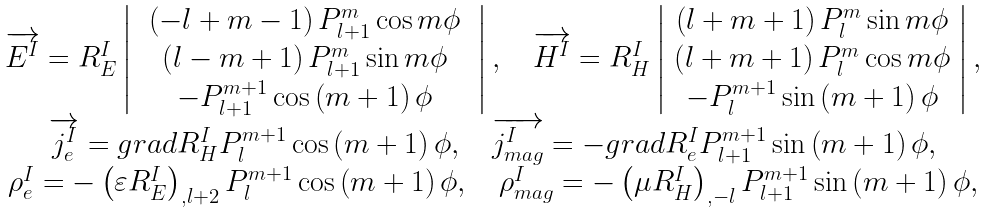Convert formula to latex. <formula><loc_0><loc_0><loc_500><loc_500>\begin{array} { c } \overrightarrow { E ^ { I } } = R _ { E } ^ { I } \left | \begin{array} { c } \begin{array} { c } \left ( - l + m - 1 \right ) P _ { l + 1 } ^ { m } \cos m \phi \\ \left ( l - m + 1 \right ) P _ { l + 1 } ^ { m } \sin m \phi \end{array} \\ - P _ { l + 1 } ^ { m + 1 } \cos \left ( m + 1 \right ) \phi \end{array} \right | , \quad \overrightarrow { H ^ { I } } = R _ { H } ^ { I } \left | \begin{array} { c } \left ( l + m + 1 \right ) P _ { l } ^ { m } \sin m \phi \\ \left ( l + m + 1 \right ) P _ { l } ^ { m } \cos m \phi \\ - P _ { l } ^ { m + 1 } \sin \left ( m + 1 \right ) \phi \end{array} \right | , \\ \overrightarrow { j _ { e } ^ { I } } = g r a d R _ { H } ^ { I } P _ { l } ^ { m + 1 } \cos \left ( m + 1 \right ) \phi , \quad \overrightarrow { j _ { m a g } ^ { I } } = - g r a d R _ { e } ^ { I } P _ { l + 1 } ^ { m + 1 } \sin \left ( m + 1 \right ) \phi , \\ \rho _ { e } ^ { I } = - \left ( \varepsilon R _ { E } ^ { I } \right ) _ { , l + 2 } P _ { l } ^ { m + 1 } \cos \left ( m + 1 \right ) \phi , \quad \rho _ { m a g } ^ { I } = - \left ( \mu R _ { H } ^ { I } \right ) _ { , - l } P _ { l + 1 } ^ { m + 1 } \sin \left ( m + 1 \right ) \phi , \end{array}</formula> 